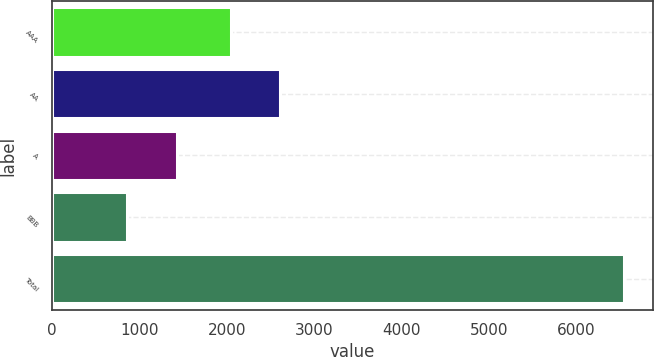Convert chart to OTSL. <chart><loc_0><loc_0><loc_500><loc_500><bar_chart><fcel>AAA<fcel>AA<fcel>A<fcel>BBB<fcel>Total<nl><fcel>2044<fcel>2613<fcel>1431<fcel>862<fcel>6552<nl></chart> 